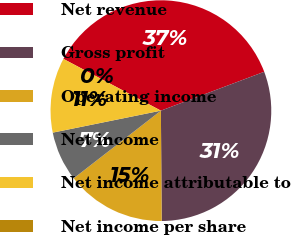Convert chart. <chart><loc_0><loc_0><loc_500><loc_500><pie_chart><fcel>Net revenue<fcel>Gross profit<fcel>Operating income<fcel>Net income<fcel>Net income attributable to<fcel>Net income per share<nl><fcel>36.51%<fcel>30.62%<fcel>14.61%<fcel>7.31%<fcel>10.96%<fcel>0.0%<nl></chart> 